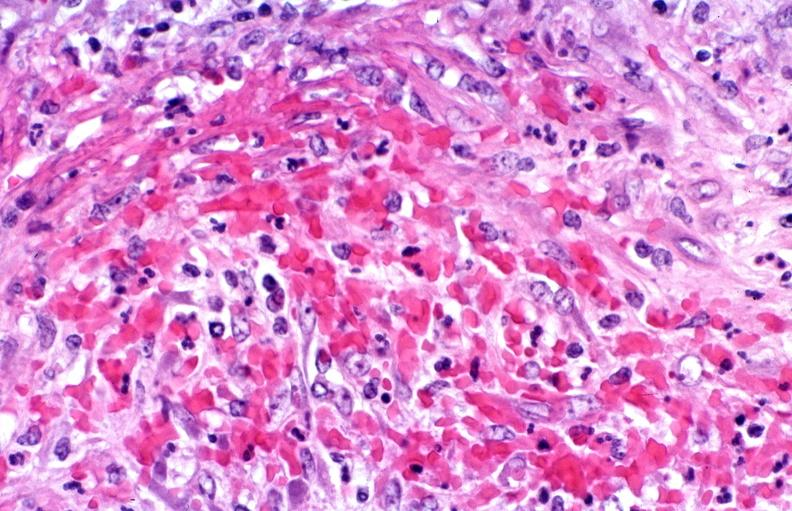s this present?
Answer the question using a single word or phrase. No 